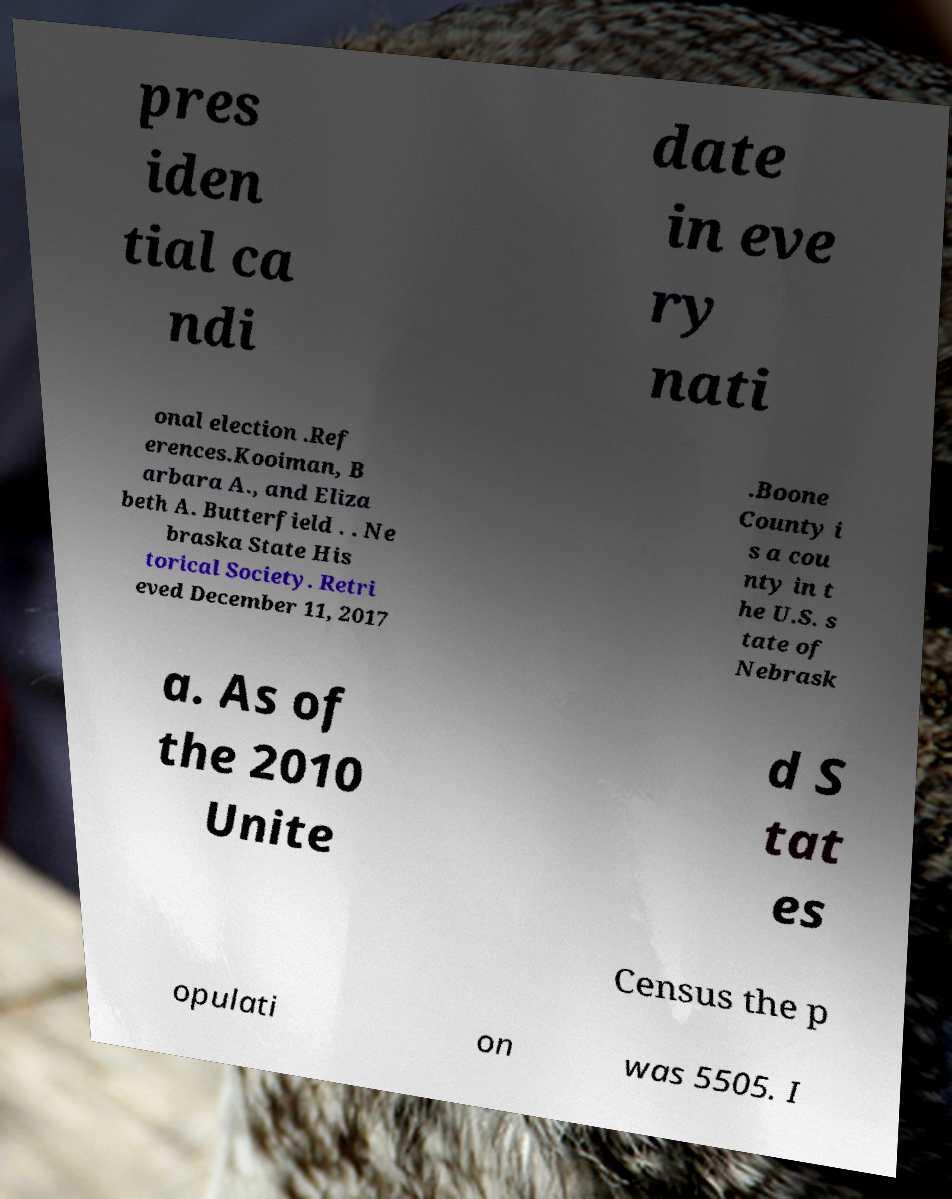Can you accurately transcribe the text from the provided image for me? pres iden tial ca ndi date in eve ry nati onal election .Ref erences.Kooiman, B arbara A., and Eliza beth A. Butterfield . . Ne braska State His torical Society. Retri eved December 11, 2017 .Boone County i s a cou nty in t he U.S. s tate of Nebrask a. As of the 2010 Unite d S tat es Census the p opulati on was 5505. I 